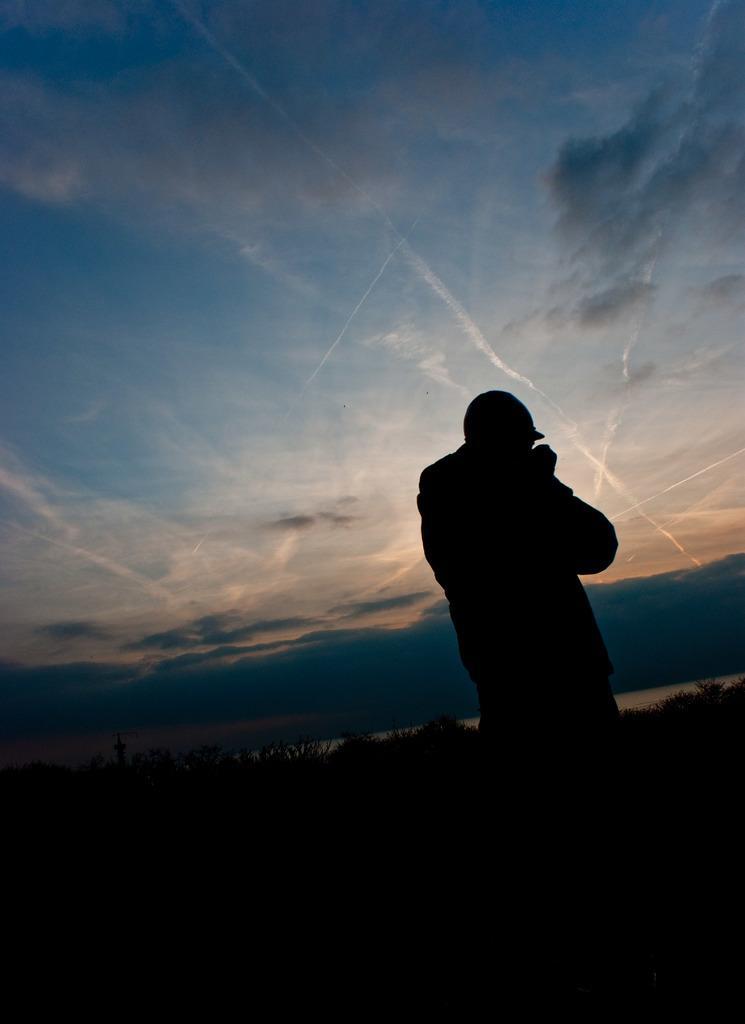In one or two sentences, can you explain what this image depicts? In this image, on the right side, we can see a person standing. In the background, we can see a water in a lake, plants. At the top, we can see a sky, at the bottom, we can see black color. 